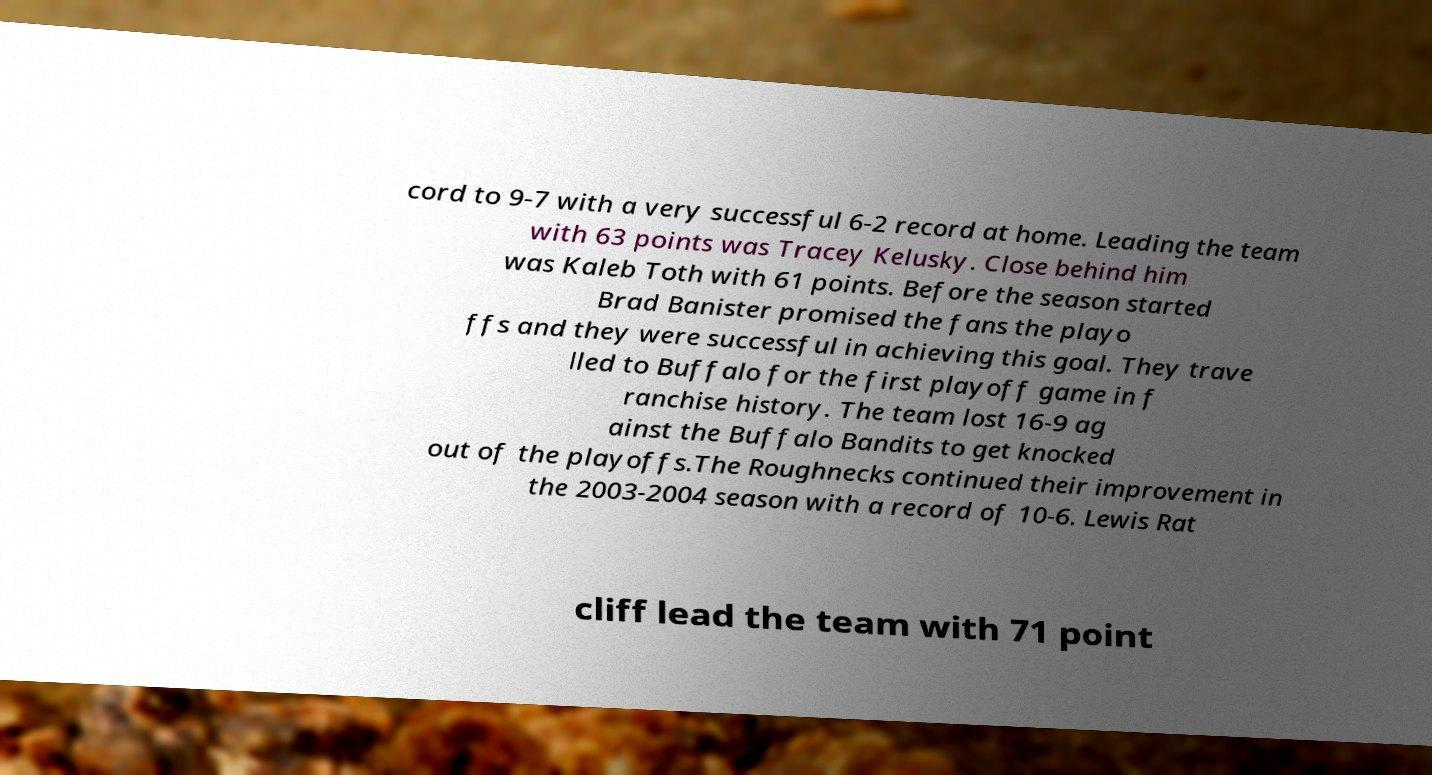Could you extract and type out the text from this image? cord to 9-7 with a very successful 6-2 record at home. Leading the team with 63 points was Tracey Kelusky. Close behind him was Kaleb Toth with 61 points. Before the season started Brad Banister promised the fans the playo ffs and they were successful in achieving this goal. They trave lled to Buffalo for the first playoff game in f ranchise history. The team lost 16-9 ag ainst the Buffalo Bandits to get knocked out of the playoffs.The Roughnecks continued their improvement in the 2003-2004 season with a record of 10-6. Lewis Rat cliff lead the team with 71 point 